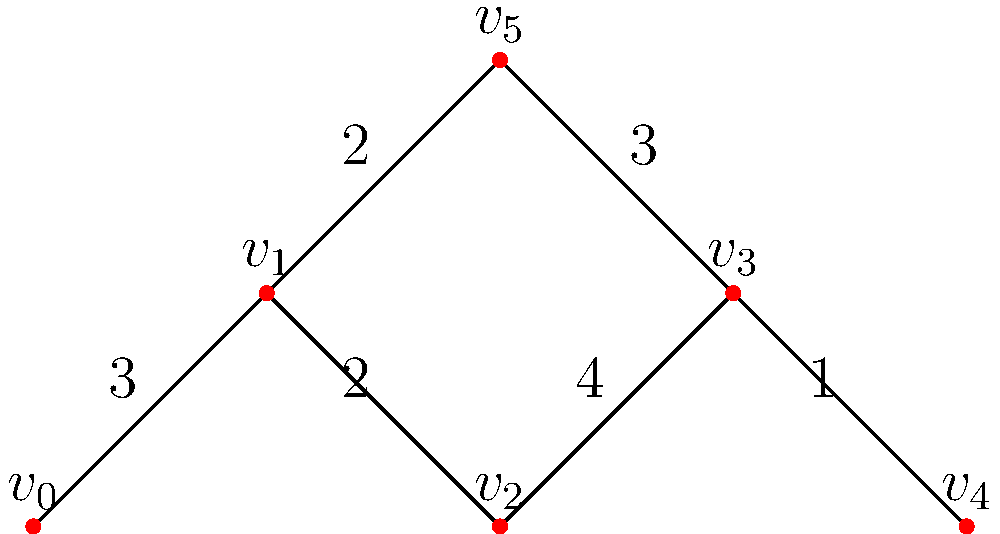Given the planar graph representing potential irrigation channels on your farm, where vertices represent junctions and edge weights represent the cost (in thousands of dollars) to construct each channel, what is the minimum total cost to connect all junctions while ensuring the system can handle frequent floods? To find the minimum total cost to connect all junctions while ensuring the system can handle frequent floods, we need to find the Minimum Spanning Tree (MST) of the given graph. The MST will provide the optimal layout for the irrigation channels that connects all junctions with the minimum total cost.

We can use Kruskal's algorithm to find the MST:

1. Sort all edges by weight in ascending order:
   $(v_3, v_4): 1$
   $(v_1, v_2): 2$
   $(v_1, v_5): 2$
   $(v_0, v_1): 3$
   $(v_3, v_5): 3$
   $(v_2, v_3): 4$

2. Start with an empty set of edges and add edges in order, skipping any that would create a cycle:
   - Add $(v_3, v_4): 1$
   - Add $(v_1, v_2): 2$
   - Add $(v_1, v_5): 2$
   - Add $(v_0, v_1): 3$
   - Add $(v_3, v_5): 3$

3. The MST is now complete with 5 edges (for 6 vertices).

4. Calculate the total cost by summing the weights of the selected edges:
   $1 + 2 + 2 + 3 + 3 = 11$

Therefore, the minimum total cost to connect all junctions is $11,000.
Answer: $11,000 